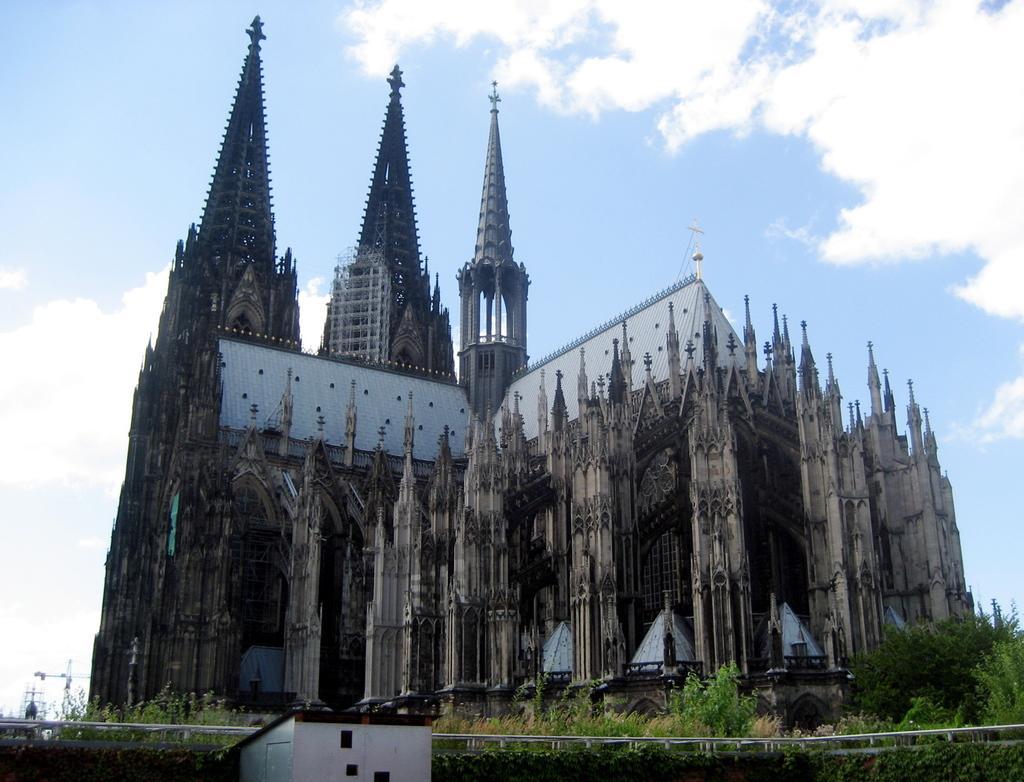Please provide a concise description of this image. In this image, we can see a building and there is a shed, a fence, trees and poles. At the top, there are clouds in the sky. 